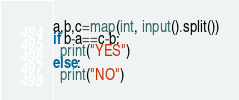<code> <loc_0><loc_0><loc_500><loc_500><_Python_>a,b,c=map(int, input().split())
if b-a==c-b:
  print("YES")
else:
  print("NO")</code> 